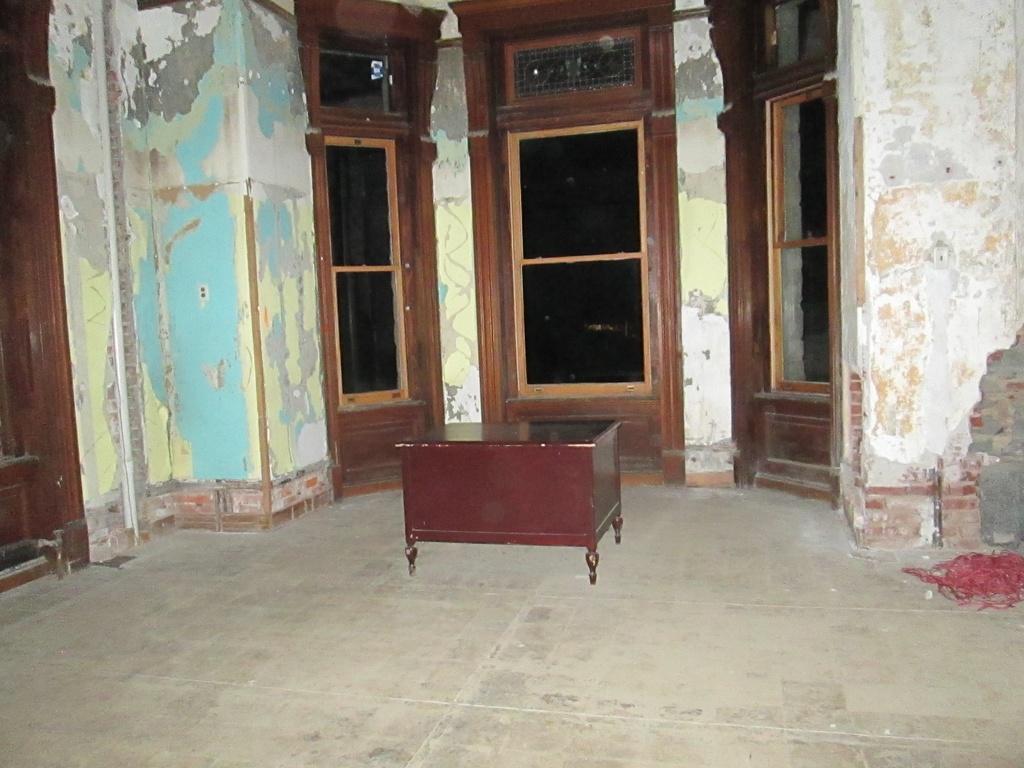In one or two sentences, can you explain what this image depicts? In this picture we can see a table and an object on the floor. Behind the table, there are doors and wall. 